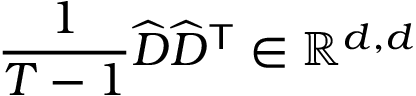Convert formula to latex. <formula><loc_0><loc_0><loc_500><loc_500>\frac { 1 } { T - 1 } \widehat { D } \widehat { D } ^ { T } \in \mathbb { R } ^ { d , d }</formula> 